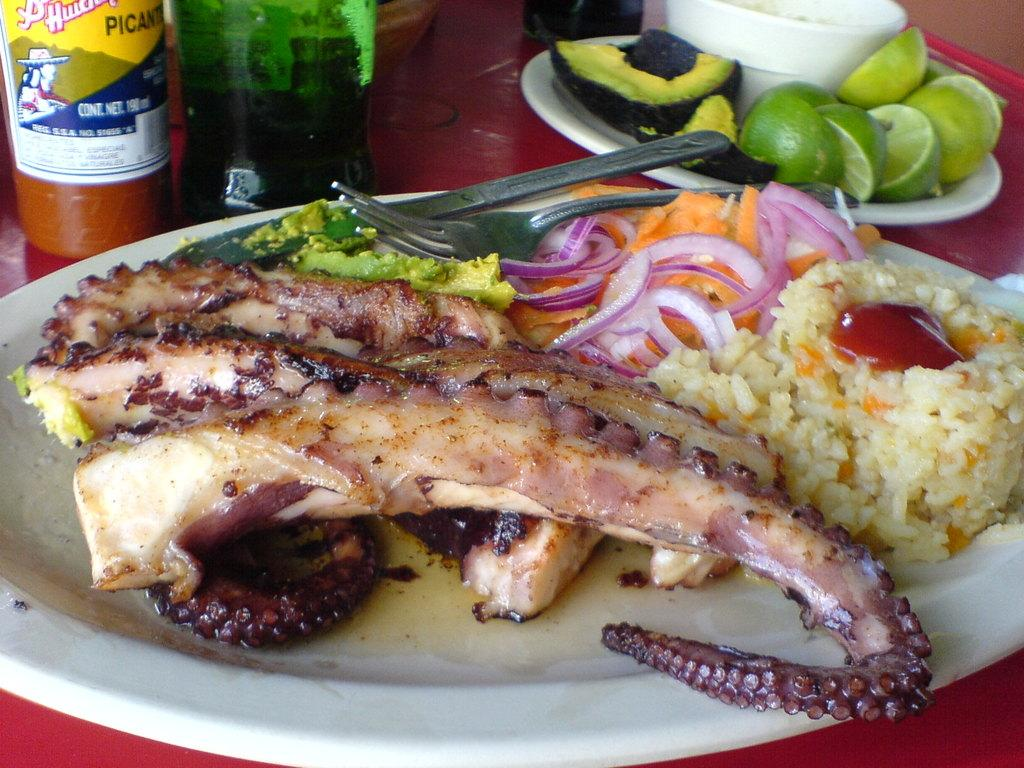What piece of furniture is present in the image? There is a table in the image. What is placed on the table? There are plates and bottles on the table. What is in the plates? There is food in the plates. What utensils are in the plates? There are knives and forks in the plates. Is there a mask floating in the liquid on the table? There is no liquid or mask present on the table in the image. 